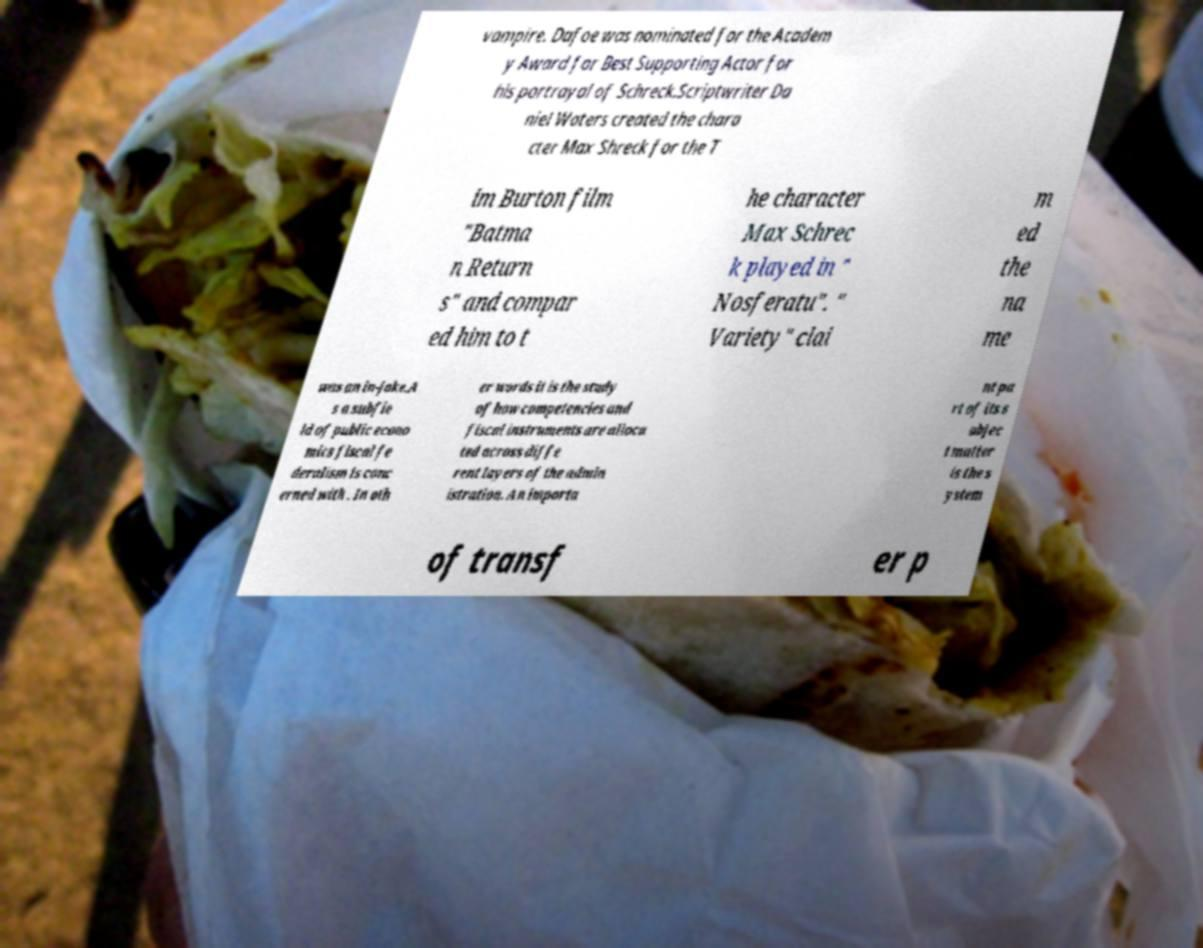Please read and relay the text visible in this image. What does it say? vampire. Dafoe was nominated for the Academ y Award for Best Supporting Actor for his portrayal of Schreck.Scriptwriter Da niel Waters created the chara cter Max Shreck for the T im Burton film "Batma n Return s" and compar ed him to t he character Max Schrec k played in " Nosferatu". " Variety" clai m ed the na me was an in-joke.A s a subfie ld of public econo mics fiscal fe deralism is conc erned with . In oth er words it is the study of how competencies and fiscal instruments are alloca ted across diffe rent layers of the admin istration. An importa nt pa rt of its s ubjec t matter is the s ystem of transf er p 